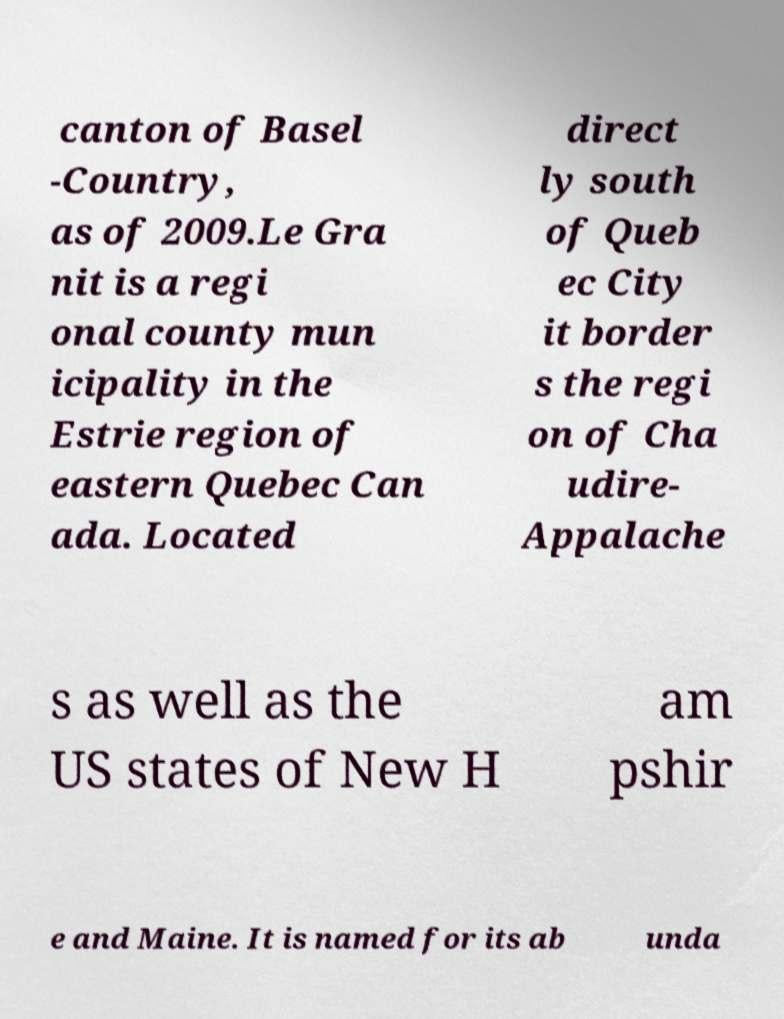Please identify and transcribe the text found in this image. canton of Basel -Country, as of 2009.Le Gra nit is a regi onal county mun icipality in the Estrie region of eastern Quebec Can ada. Located direct ly south of Queb ec City it border s the regi on of Cha udire- Appalache s as well as the US states of New H am pshir e and Maine. It is named for its ab unda 